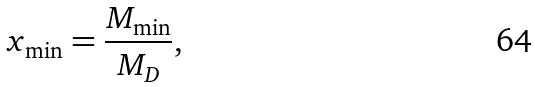<formula> <loc_0><loc_0><loc_500><loc_500>x _ { \min } = \frac { M _ { \min } } { M _ { D } } ,</formula> 